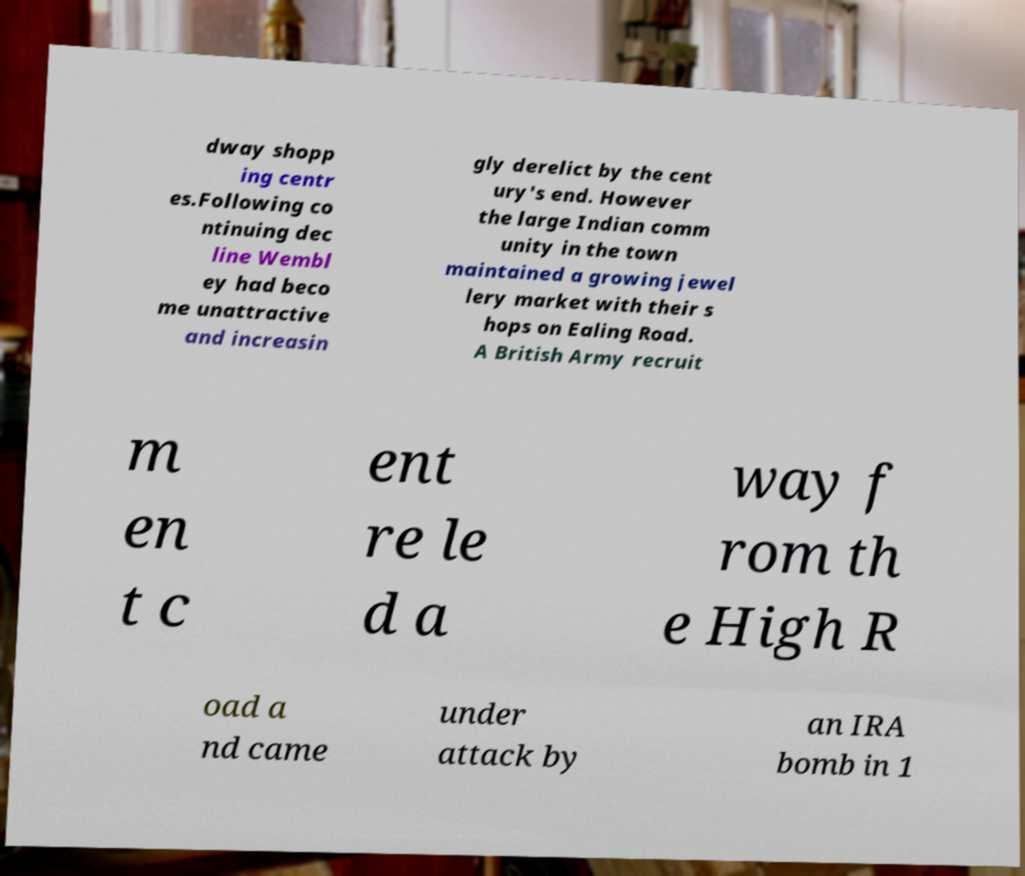Please read and relay the text visible in this image. What does it say? dway shopp ing centr es.Following co ntinuing dec line Wembl ey had beco me unattractive and increasin gly derelict by the cent ury's end. However the large Indian comm unity in the town maintained a growing jewel lery market with their s hops on Ealing Road. A British Army recruit m en t c ent re le d a way f rom th e High R oad a nd came under attack by an IRA bomb in 1 